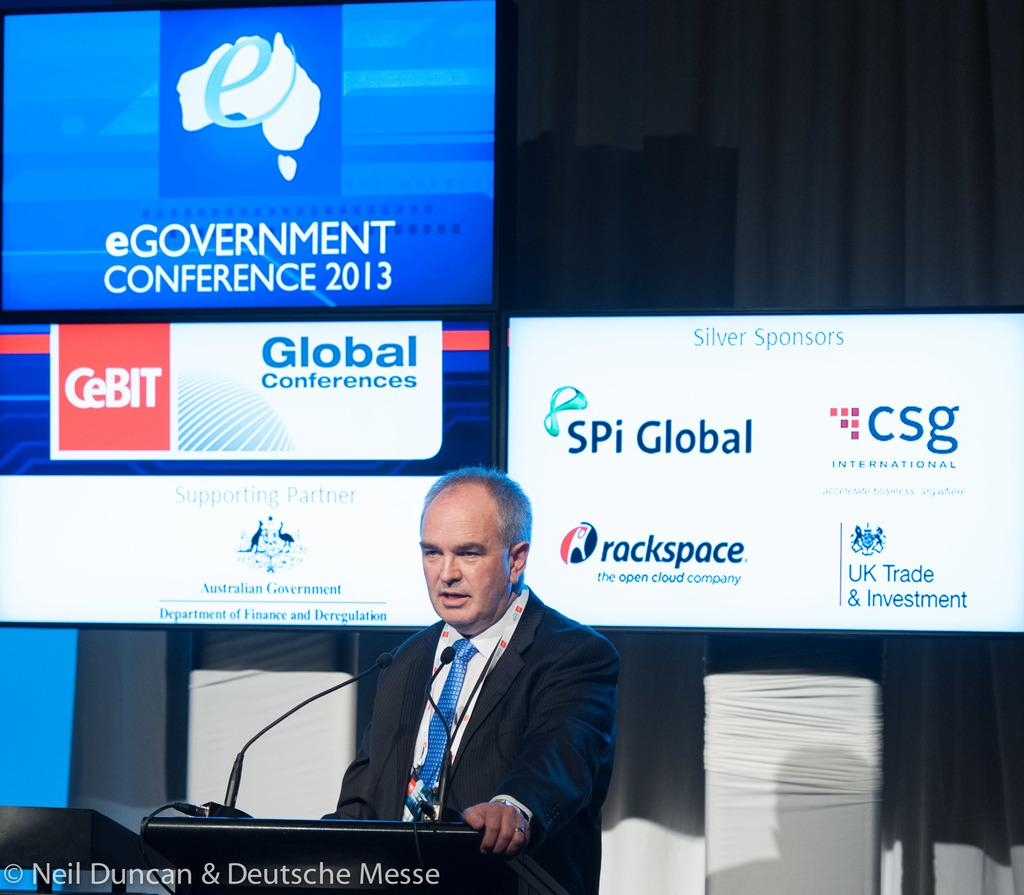<image>
Relay a brief, clear account of the picture shown. A man stands behind a podium at the eGovernment Conference 2013. 